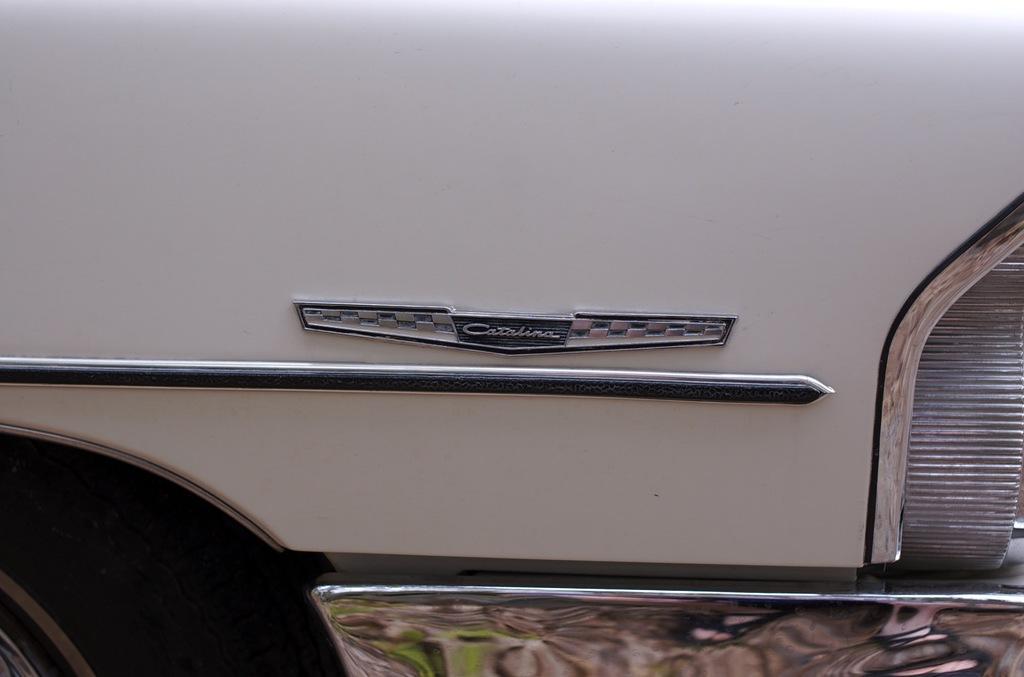Describe this image in one or two sentences. Here in this picture we can see a close up view of a car from side and we can see a logo present on it and we can also see a light present on the right side and on the left side we can see a wheel with Tyre present. 